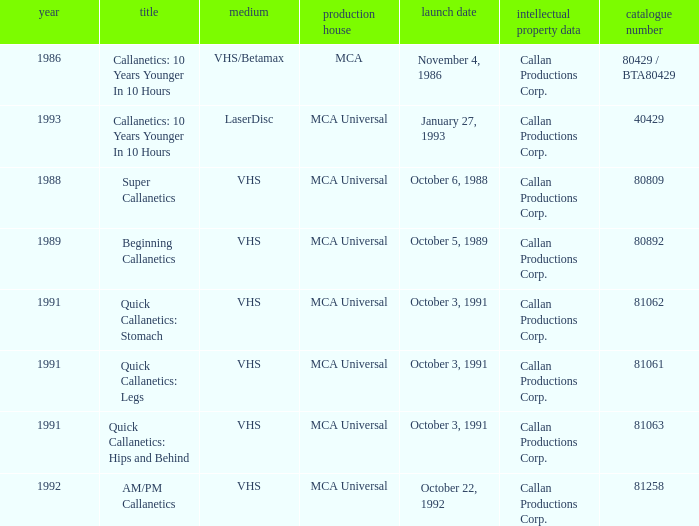Name the catalog number for am/pm callanetics 81258.0. 